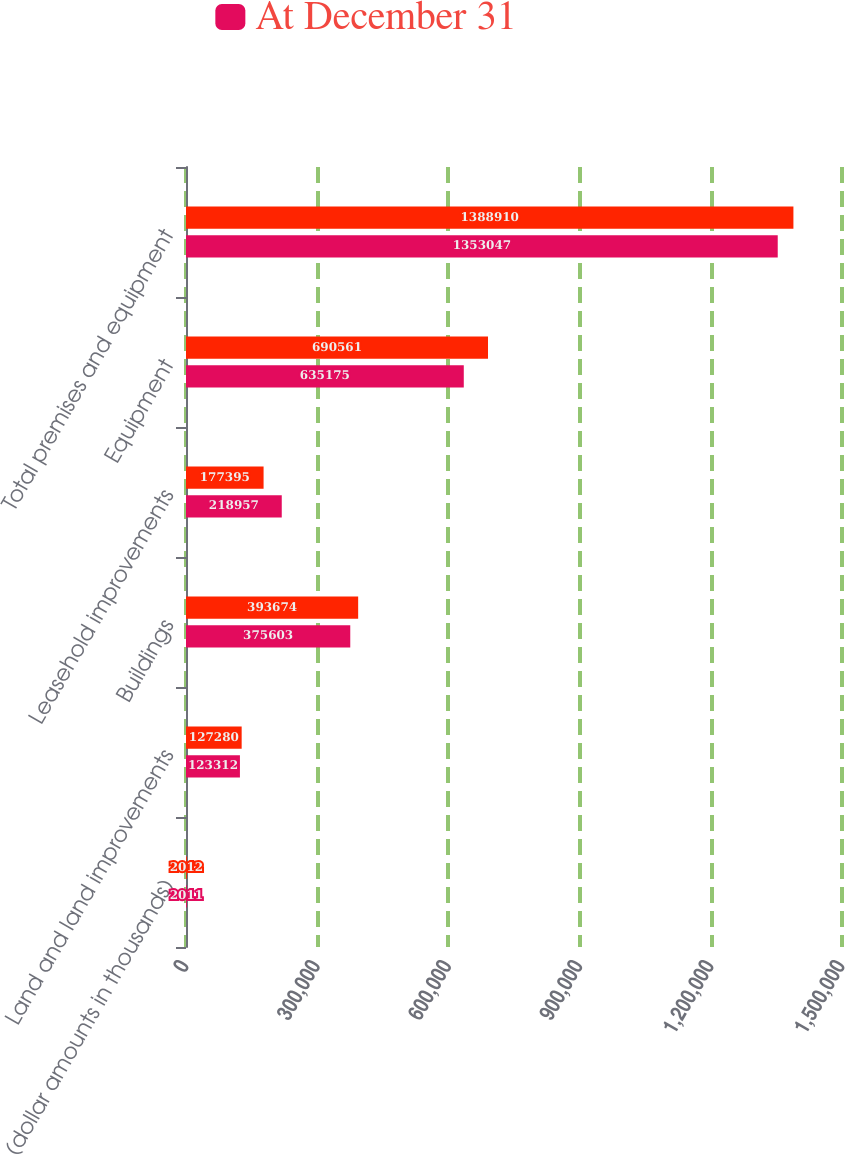<chart> <loc_0><loc_0><loc_500><loc_500><stacked_bar_chart><ecel><fcel>(dollar amounts in thousands)<fcel>Land and land improvements<fcel>Buildings<fcel>Leasehold improvements<fcel>Equipment<fcel>Total premises and equipment<nl><fcel>nan<fcel>2012<fcel>127280<fcel>393674<fcel>177395<fcel>690561<fcel>1.38891e+06<nl><fcel>At December 31<fcel>2011<fcel>123312<fcel>375603<fcel>218957<fcel>635175<fcel>1.35305e+06<nl></chart> 